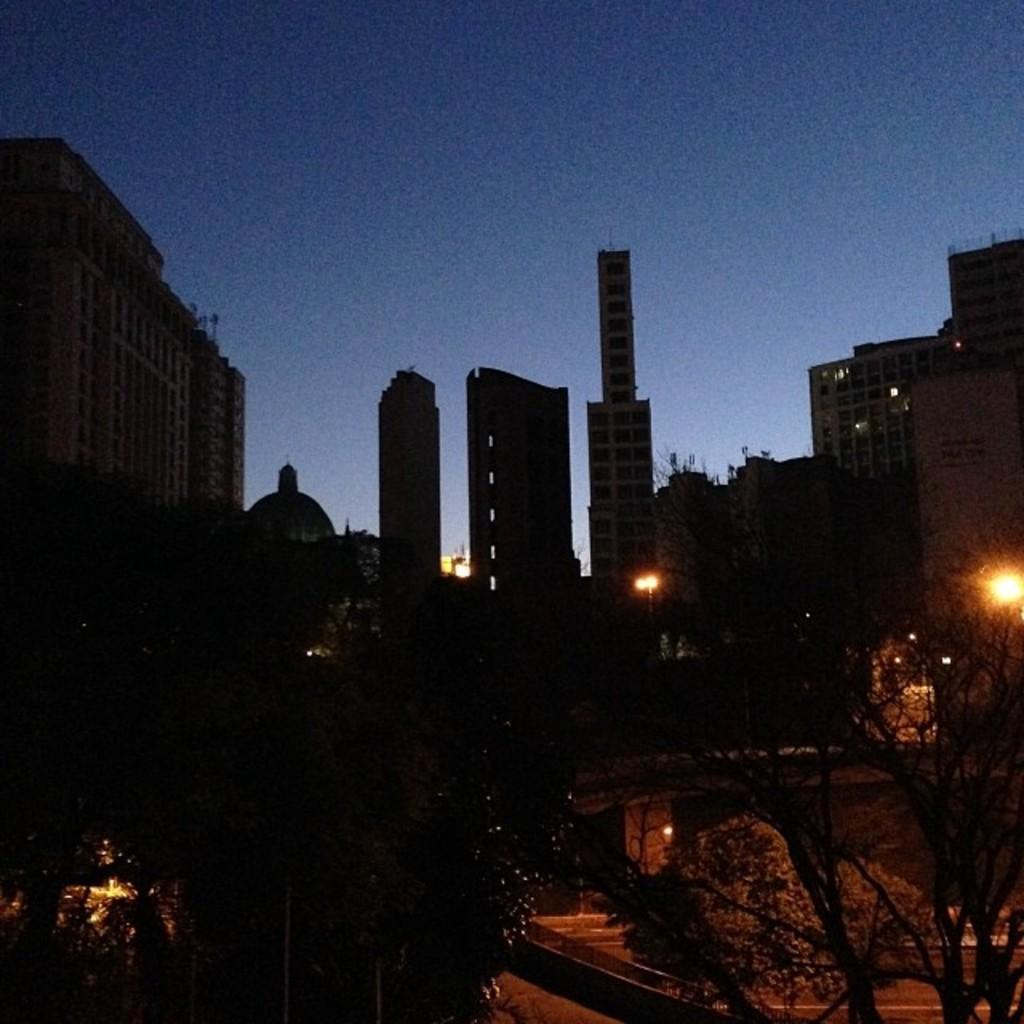Describe this image in one or two sentences. These are the buildings in the long back side and here there are trees. 